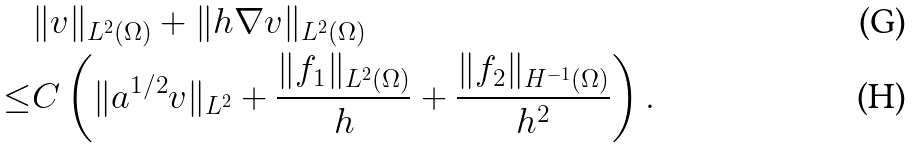<formula> <loc_0><loc_0><loc_500><loc_500>& \| v \| _ { L ^ { 2 } ( \Omega ) } + \| h \nabla v \| _ { L ^ { 2 } ( \Omega ) } \\ \leq & C \left ( \| a ^ { 1 / 2 } v \| _ { L ^ { 2 } } + \frac { \| f _ { 1 } \| _ { L ^ { 2 } ( \Omega ) } } { h } + \frac { \| f _ { 2 } \| _ { H ^ { - 1 } ( \Omega ) } } { h ^ { 2 } } \right ) .</formula> 